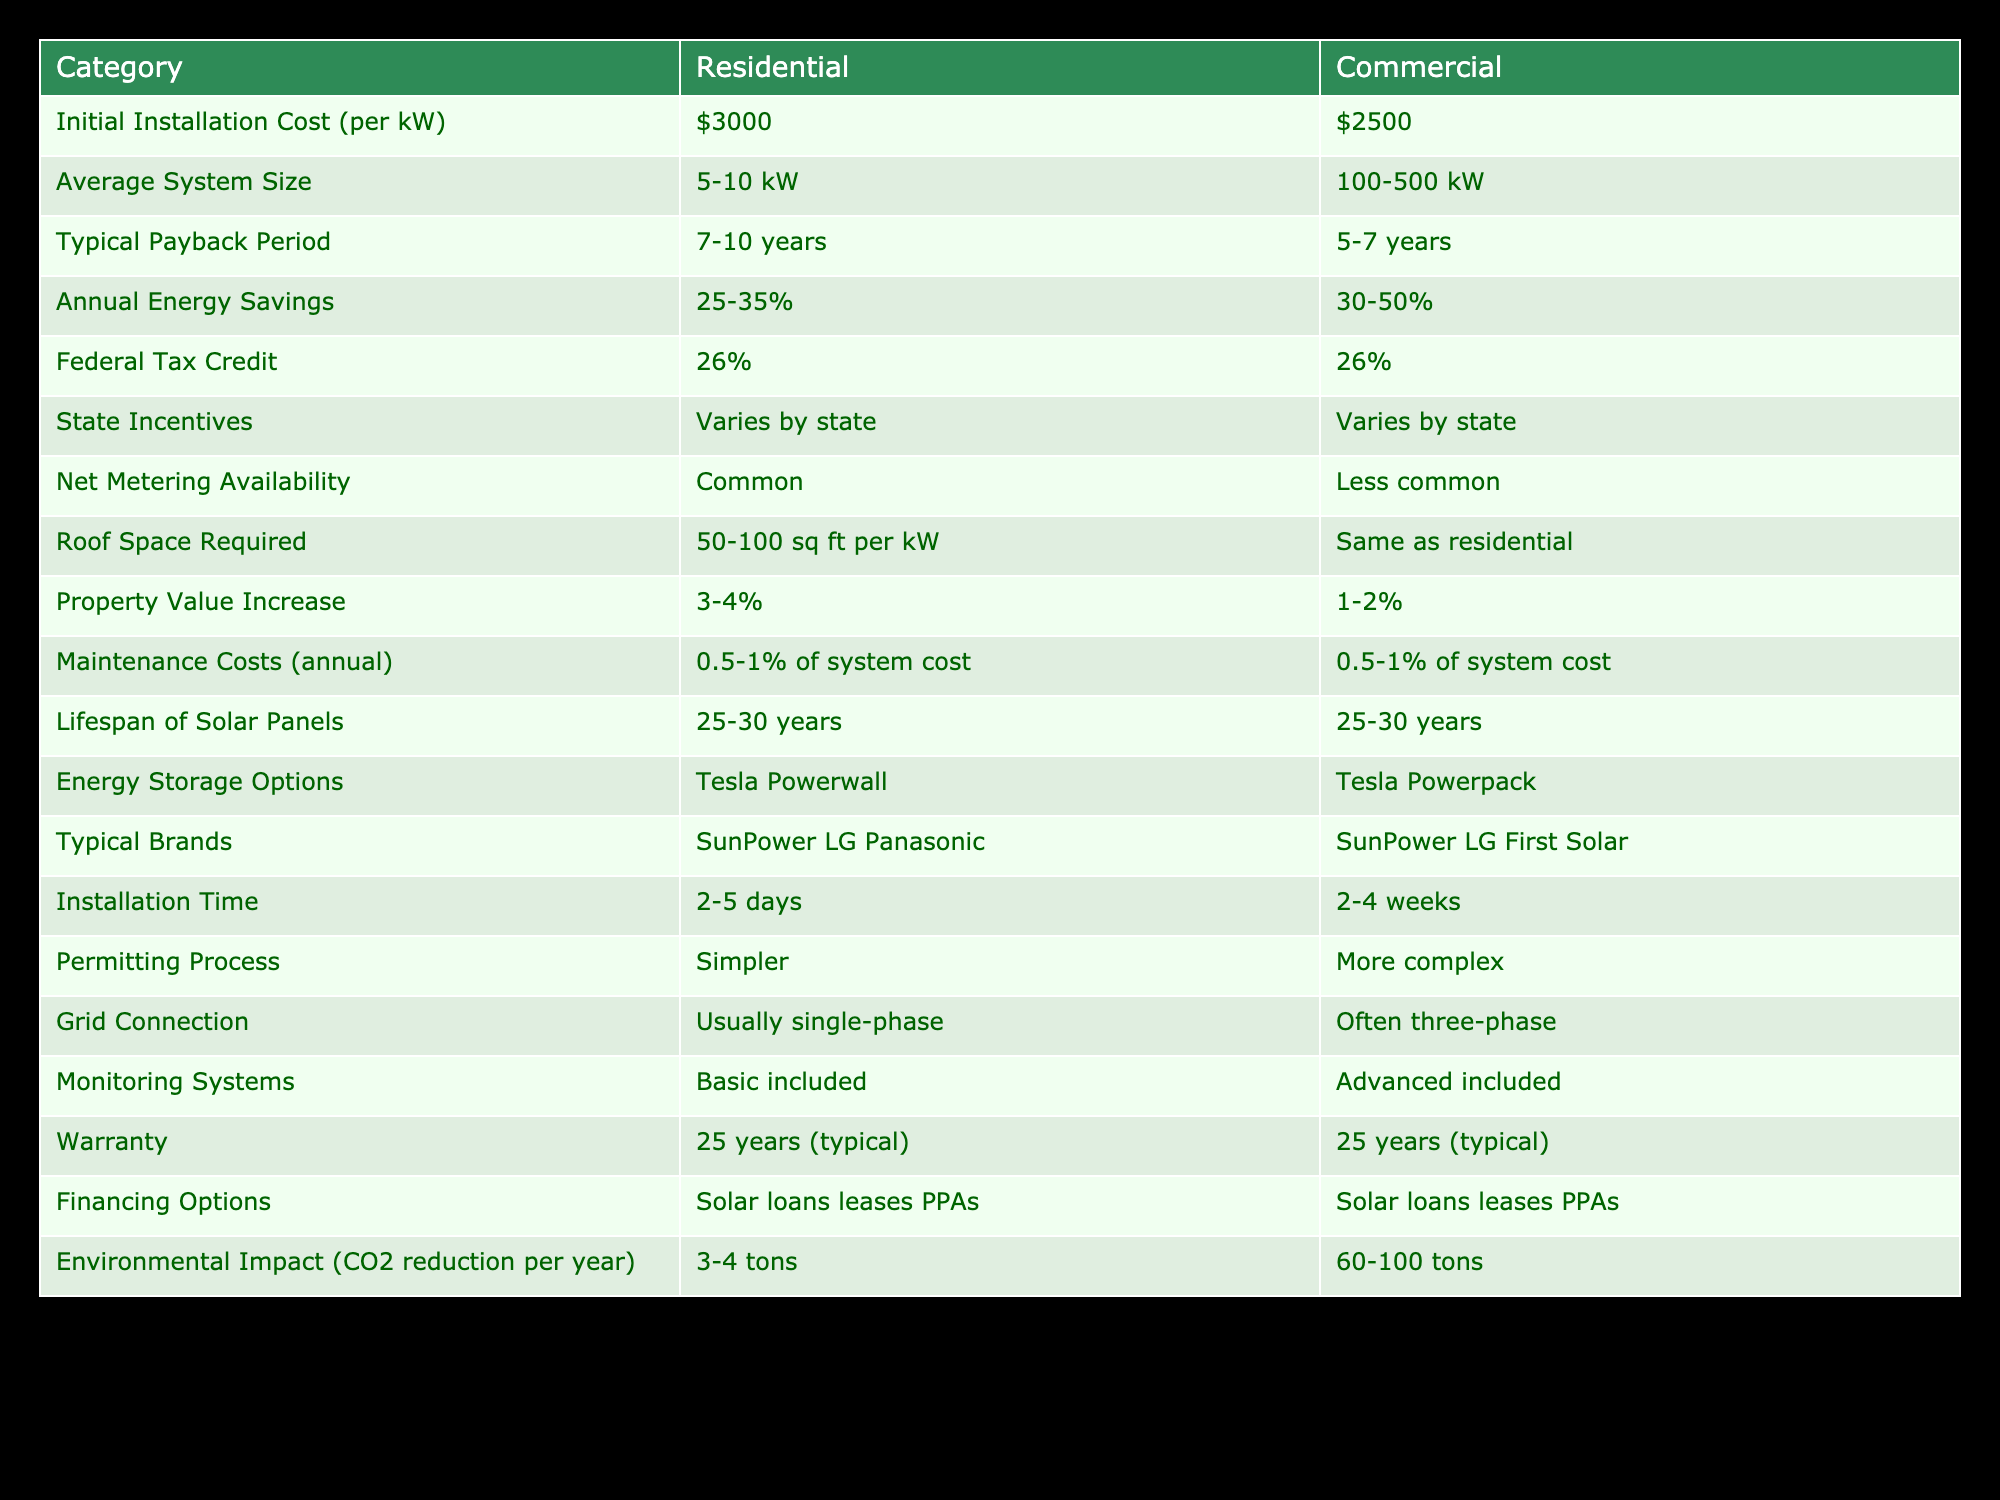What is the initial installation cost per kW for residential properties? The table indicates that the initial installation cost per kW for residential properties is $3000.
Answer: $3000 What is the typical payback period for commercial solar installations? According to the table, the typical payback period for commercial solar installations ranges from 5 to 7 years.
Answer: 5-7 years Is net metering availability more common for residential or commercial installations? The table states that net metering availability is common for residential installations but less common for commercial installations.
Answer: Residential What are the annual energy savings percentages for residential and commercial properties? The annual energy savings for residential properties are between 25-35%, while for commercial properties they are between 30-50%.
Answer: Residential: 25-35%, Commercial: 30-50% How much higher is the average system size for commercial compared to residential properties? The average system size for residential properties ranges from 5-10 kW, while for commercial properties it ranges from 100-500 kW. To find the difference, we can take an average for each category: Residential average is (5+10)/2 = 7.5 kW and Commercial average is (100+500)/2 = 300 kW. Therefore, the difference is 300 - 7.5 = 292.5 kW.
Answer: 292.5 kW Which category has a higher property value increase from solar installations? The table shows that residential properties see a property value increase of 3-4%, whereas commercial properties see an increase of 1-2%. Thus, residential properties have a higher value increase.
Answer: Residential What is the lifespan of solar panels for both residential and commercial properties? The table notes that the lifespan of solar panels is the same for both categories: 25-30 years.
Answer: 25-30 years Does each category have the same annual maintenance costs? Yes, the table indicates that maintenance costs are both 0.5-1% of the system cost for residential and commercial properties.
Answer: Yes Which property type produces more CO2 reduction per year with solar installations? The table specifies that residential installations reduce approximately 3-4 tons of CO2 per year, while commercial installations reduce 60-100 tons. Thus, commercial installations produce more CO2 reduction.
Answer: Commercial 